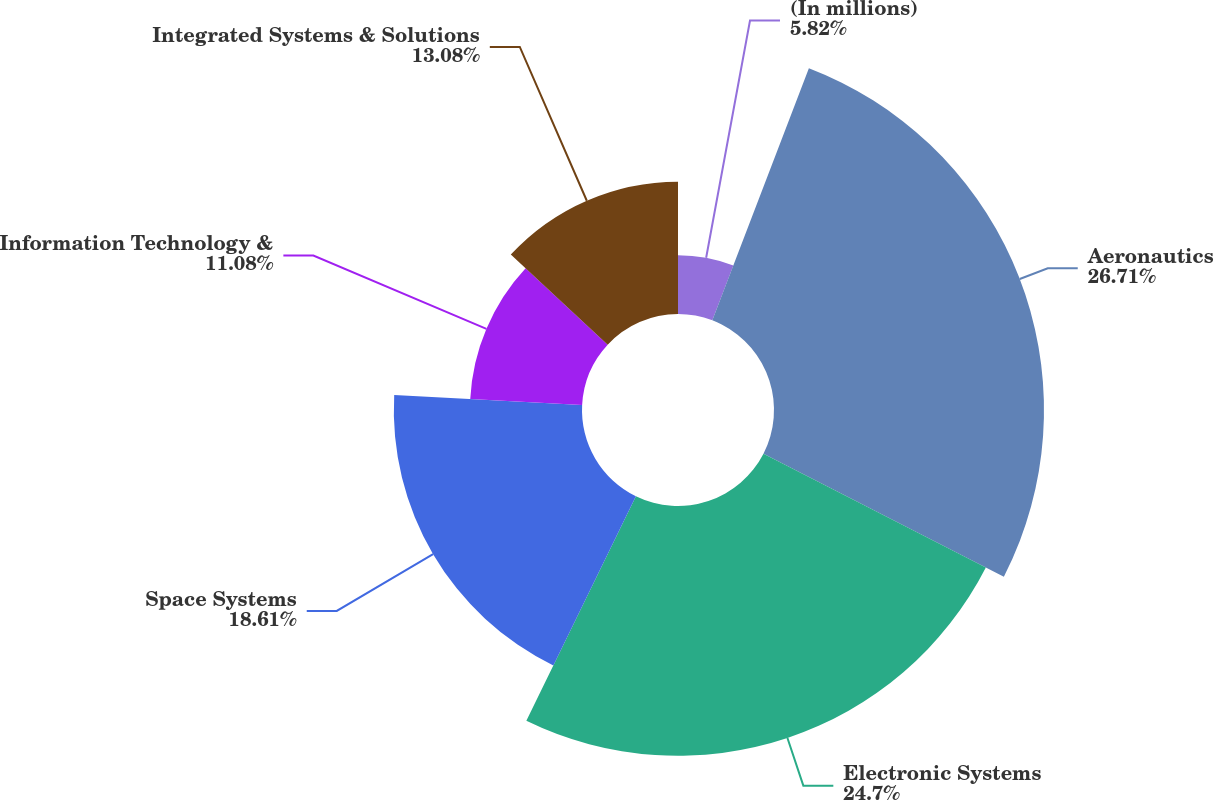<chart> <loc_0><loc_0><loc_500><loc_500><pie_chart><fcel>(In millions)<fcel>Aeronautics<fcel>Electronic Systems<fcel>Space Systems<fcel>Information Technology &<fcel>Integrated Systems & Solutions<nl><fcel>5.82%<fcel>26.7%<fcel>24.7%<fcel>18.61%<fcel>11.08%<fcel>13.08%<nl></chart> 